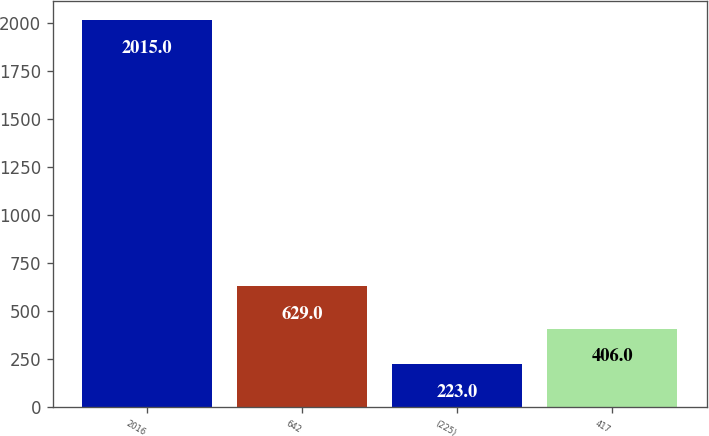Convert chart to OTSL. <chart><loc_0><loc_0><loc_500><loc_500><bar_chart><fcel>2016<fcel>642<fcel>(225)<fcel>417<nl><fcel>2015<fcel>629<fcel>223<fcel>406<nl></chart> 